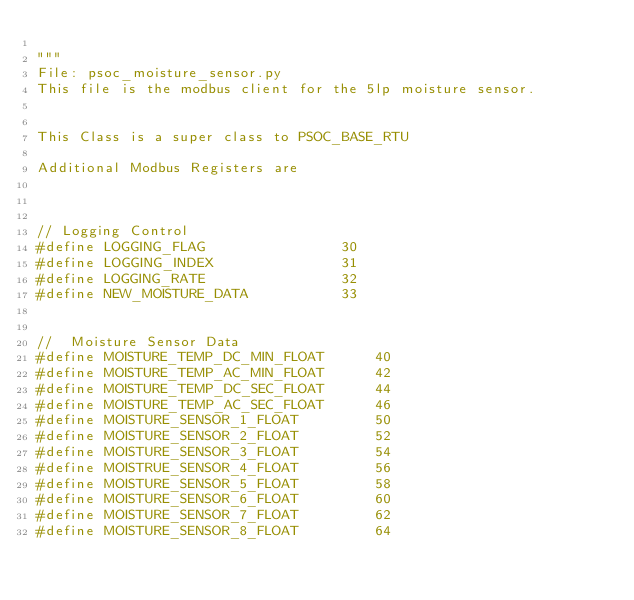Convert code to text. <code><loc_0><loc_0><loc_500><loc_500><_Python_>
"""
File: psoc_moisture_sensor.py
This file is the modbus client for the 5lp moisture sensor.


This Class is a super class to PSOC_BASE_RTU

Additional Modbus Registers are 

       
         
// Logging Control
#define LOGGING_FLAG                30
#define LOGGING_INDEX               31
#define LOGGING_RATE                32
#define NEW_MOISTURE_DATA           33


//  Moisture Sensor Data
#define MOISTURE_TEMP_DC_MIN_FLOAT      40
#define MOISTURE_TEMP_AC_MIN_FLOAT      42
#define MOISTURE_TEMP_DC_SEC_FLOAT      44
#define MOISTURE_TEMP_AC_SEC_FLOAT      46
#define MOISTURE_SENSOR_1_FLOAT         50
#define MOISTURE_SENSOR_2_FLOAT         52
#define MOISTURE_SENSOR_3_FLOAT         54
#define MOISTRUE_SENSOR_4_FLOAT         56
#define MOISTURE_SENSOR_5_FLOAT         58
#define MOISTURE_SENSOR_6_FLOAT         60
#define MOISTURE_SENSOR_7_FLOAT         62
#define MOISTURE_SENSOR_8_FLOAT         64   </code> 